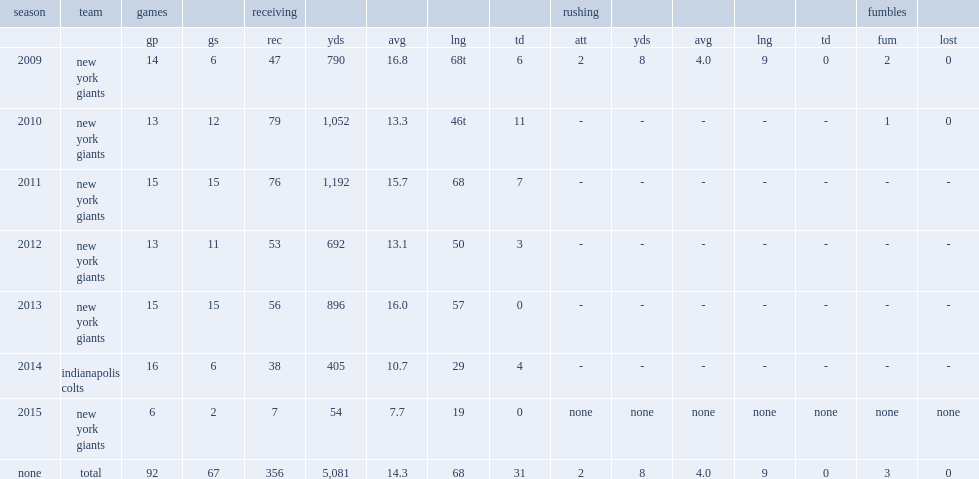How many receptions did hakeem nicks get in 2010? 79.0. 